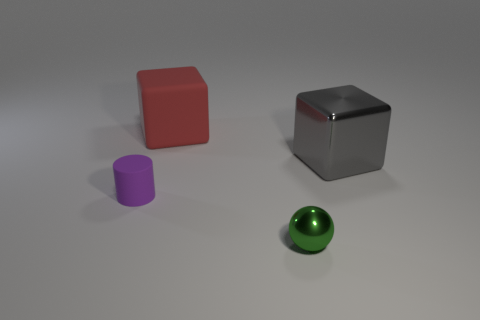Add 1 large metal objects. How many objects exist? 5 Subtract all cylinders. How many objects are left? 3 Add 1 tiny balls. How many tiny balls are left? 2 Add 3 purple cylinders. How many purple cylinders exist? 4 Subtract 0 purple blocks. How many objects are left? 4 Subtract all small green matte cylinders. Subtract all green metal things. How many objects are left? 3 